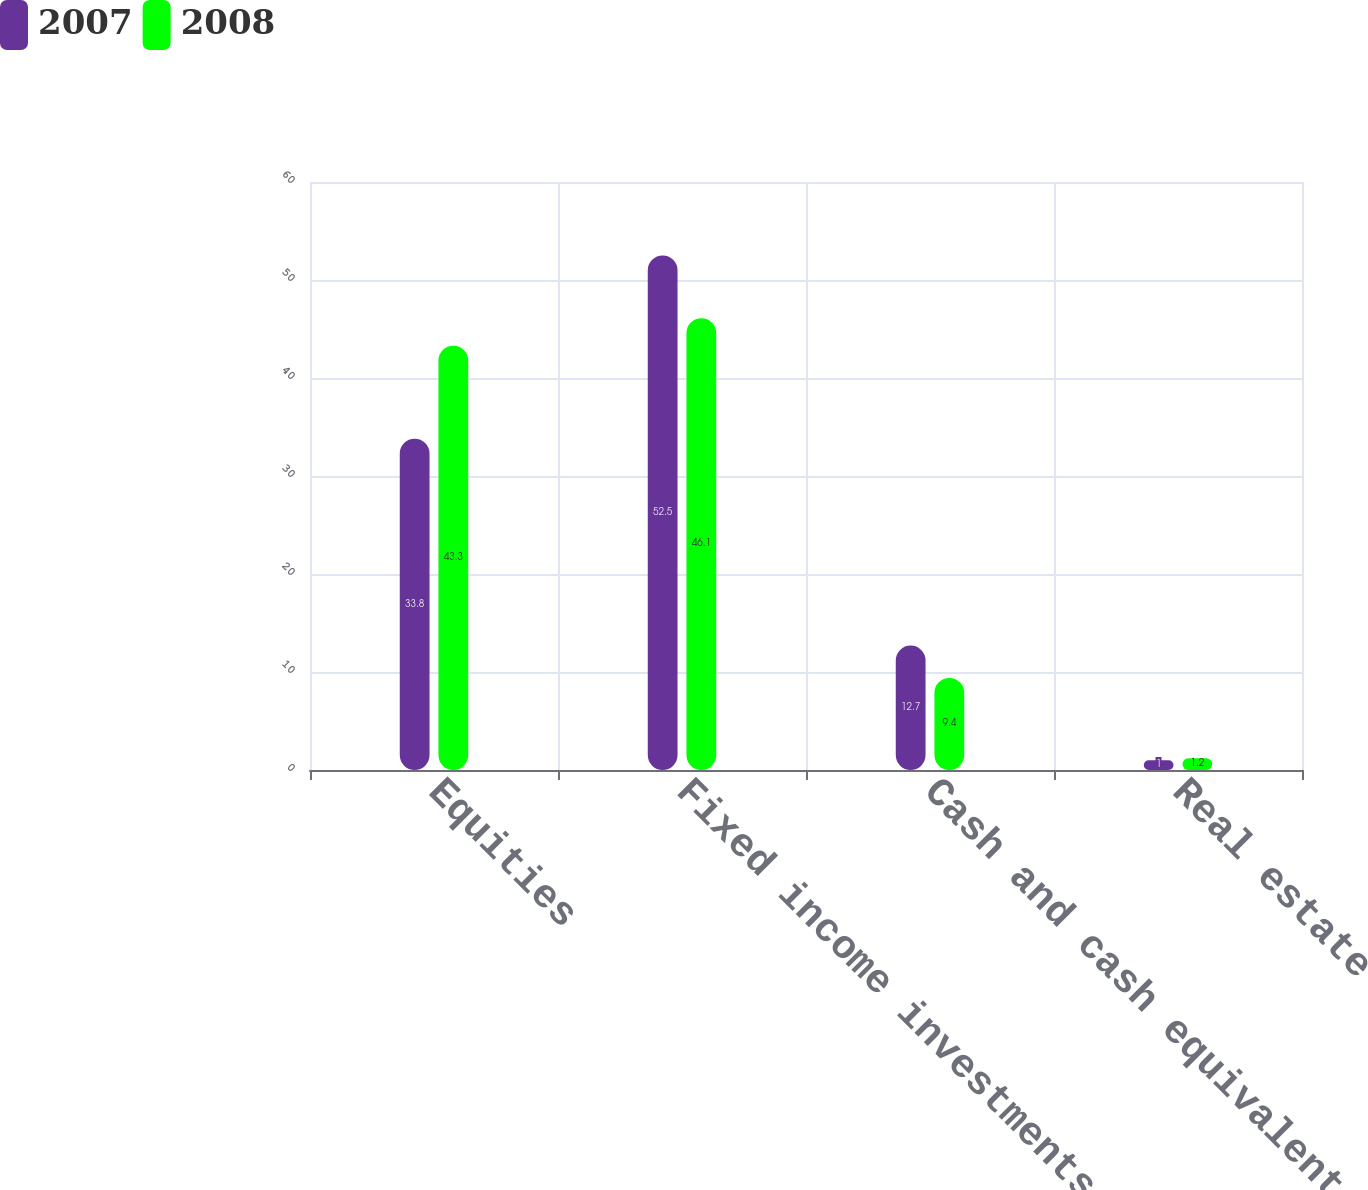Convert chart to OTSL. <chart><loc_0><loc_0><loc_500><loc_500><stacked_bar_chart><ecel><fcel>Equities<fcel>Fixed income investments<fcel>Cash and cash equivalents<fcel>Real estate<nl><fcel>2007<fcel>33.8<fcel>52.5<fcel>12.7<fcel>1<nl><fcel>2008<fcel>43.3<fcel>46.1<fcel>9.4<fcel>1.2<nl></chart> 